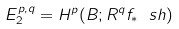<formula> <loc_0><loc_0><loc_500><loc_500>E _ { 2 } ^ { p , q } = H ^ { p } ( B ; R ^ { q } f _ { * } \ s h )</formula> 